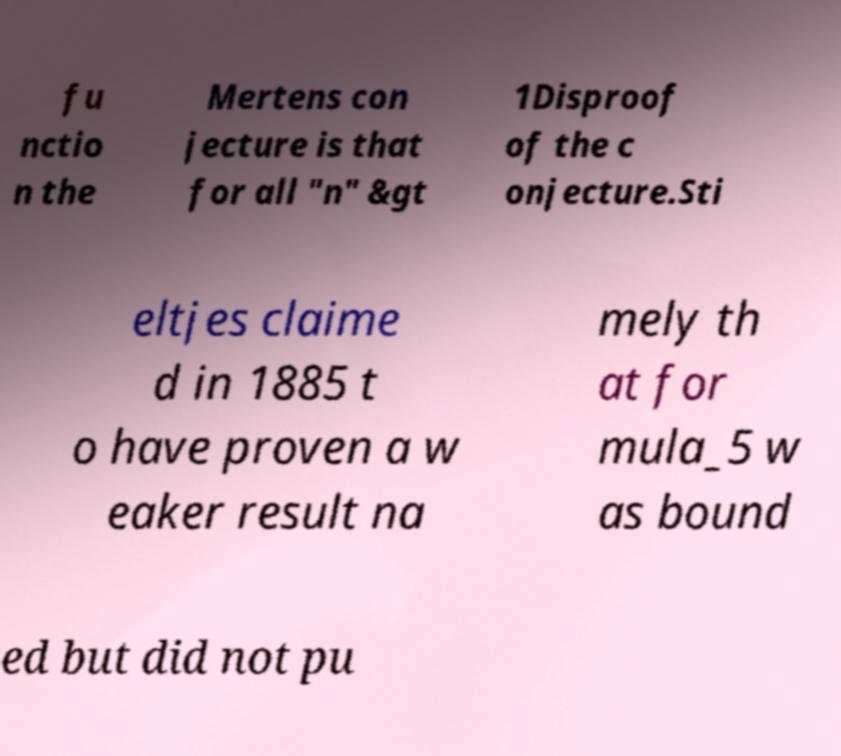Could you assist in decoding the text presented in this image and type it out clearly? fu nctio n the Mertens con jecture is that for all "n" &gt 1Disproof of the c onjecture.Sti eltjes claime d in 1885 t o have proven a w eaker result na mely th at for mula_5 w as bound ed but did not pu 